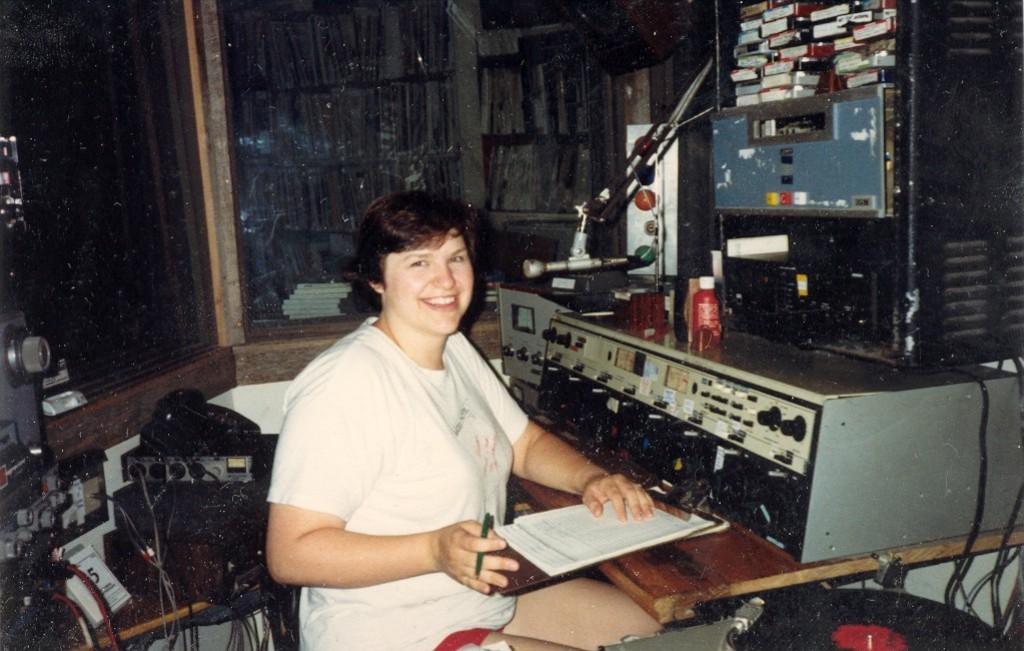In one or two sentences, can you explain what this image depicts? In this picture I can see a woman sitting in front and I see that she is smiling. I can also see that, she is holding a pen and I see many papers under her hand. I can also see that, there are many equipment around. In the background I can see the books. 